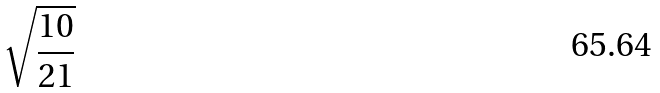<formula> <loc_0><loc_0><loc_500><loc_500>\sqrt { \frac { 1 0 } { 2 1 } }</formula> 